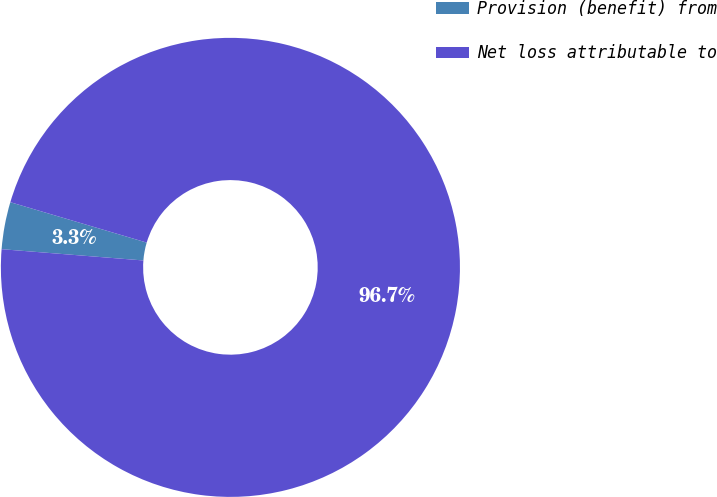Convert chart to OTSL. <chart><loc_0><loc_0><loc_500><loc_500><pie_chart><fcel>Provision (benefit) from<fcel>Net loss attributable to<nl><fcel>3.32%<fcel>96.68%<nl></chart> 